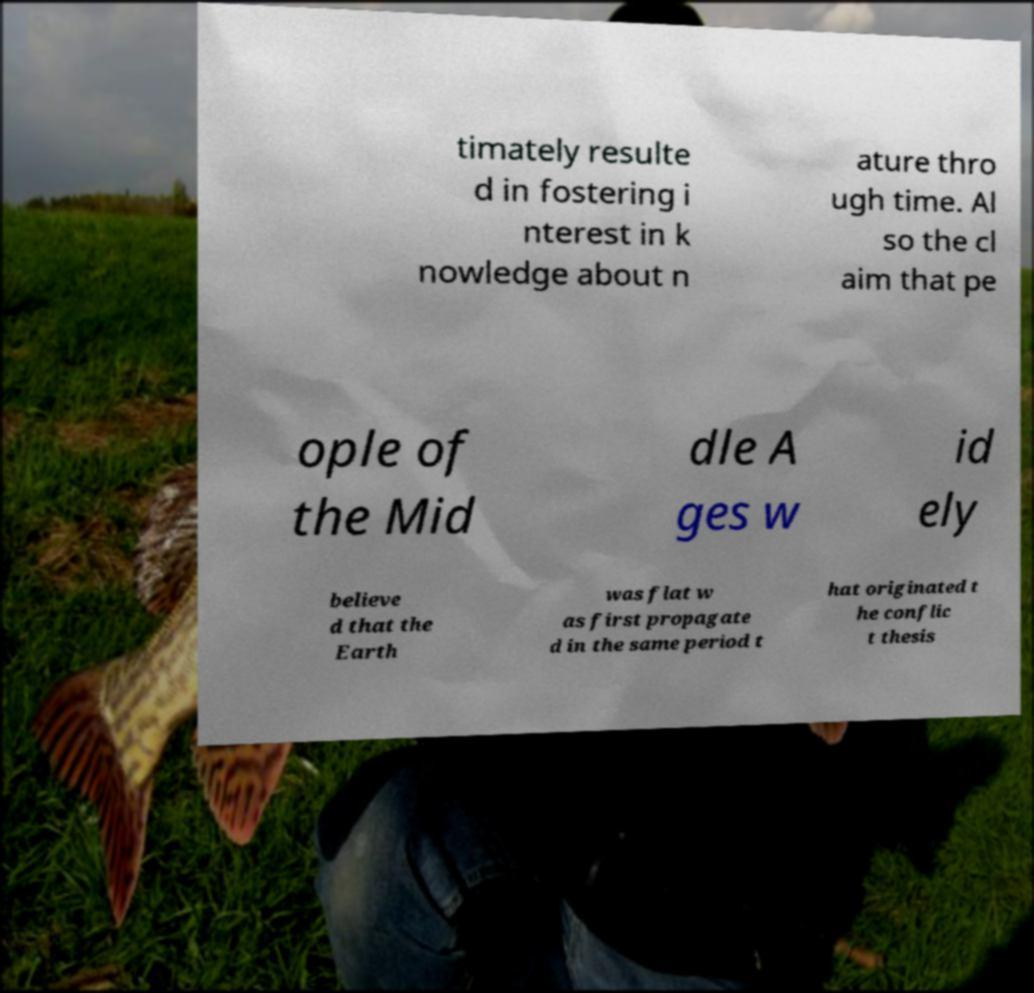I need the written content from this picture converted into text. Can you do that? timately resulte d in fostering i nterest in k nowledge about n ature thro ugh time. Al so the cl aim that pe ople of the Mid dle A ges w id ely believe d that the Earth was flat w as first propagate d in the same period t hat originated t he conflic t thesis 